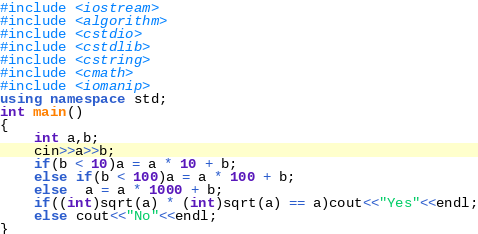<code> <loc_0><loc_0><loc_500><loc_500><_C++_>#include <iostream>
#include <algorithm>
#include <cstdio>
#include <cstdlib>
#include <cstring>
#include <cmath>
#include <iomanip>
using namespace std;
int main()
{
    int a,b;
    cin>>a>>b;
    if(b < 10)a = a * 10 + b;
    else if(b < 100)a = a * 100 + b;
    else  a = a * 1000 + b;
    if((int)sqrt(a) * (int)sqrt(a) == a)cout<<"Yes"<<endl;
    else cout<<"No"<<endl;
}
</code> 